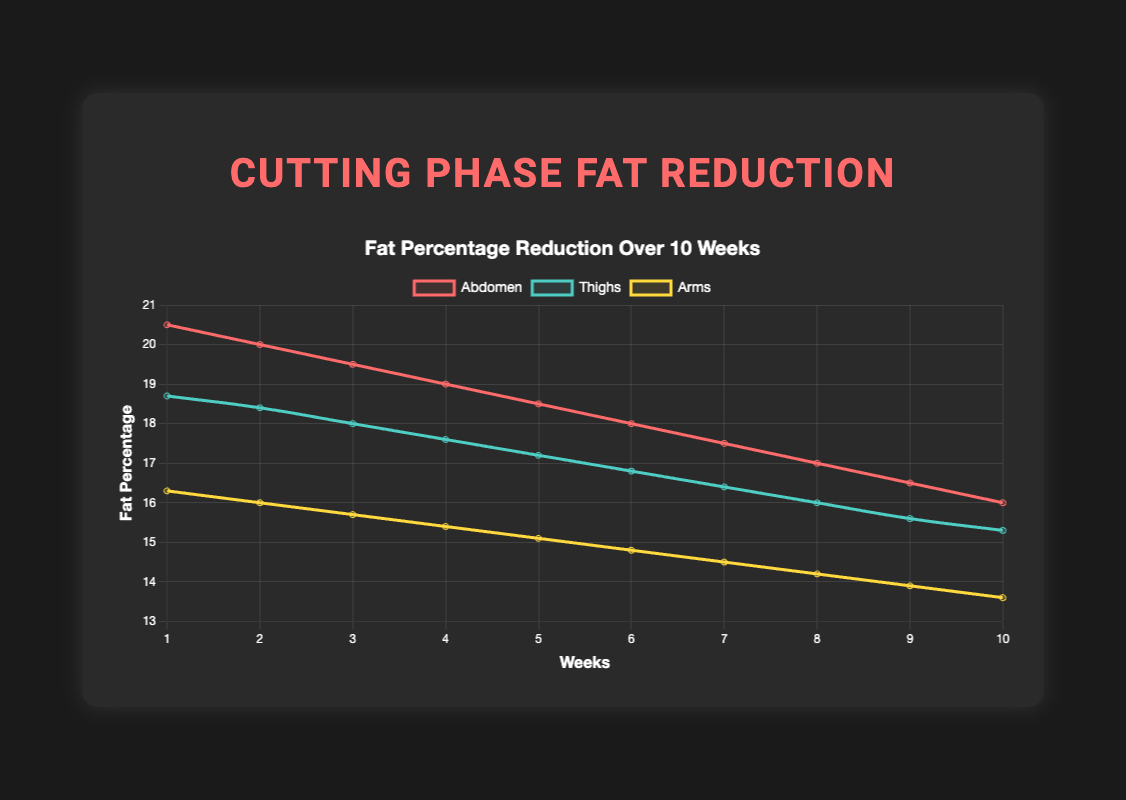What is the initial fat percentage in the abdomen compared to the arms? To determine the initial fat percentages, refer to the y-values at week 1 for the abdomen and arms. The fat percentage for the abdomen is 20.5% and for the arms is 16.3%. Comparing these values, the abdomen fat percentage is higher.
Answer: The abdomen has a higher initial fat percentage than the arms How much total fat percentage reduction is seen in the thighs by week 10? Calculate the difference in fat percentage from week 1 to week 10 for the thighs. The initial fat percentage at week 1 is 18.7% and at week 10 is 15.3%. Subtract the final value from the initial value to get the total reduction: 18.7% - 15.3% = 3.4%.
Answer: 3.4% Which body part has the most significant decrease in fat percentage over 10 weeks? Compare the total reduction in fat percentage from week 1 to week 10 for the abdomen, thighs, and arms. The abdomen reduces from 20.5% to 16.0%, a difference of 4.5%. Thighs reduce from 18.7% to 15.3%, a difference of 3.4%. Arms reduce from 16.3% to 13.6%, a difference of 2.7%. The abdomen shows the most significant decrease of 4.5%.
Answer: Abdomen At week 5, which body part has the lowest fat percentage? Examine the fat percentages at week 5 for the abdomen, thighs, and arms. The values are: Abdomen: 18.5%, Thighs: 17.2%, Arms: 15.1%. The arms have the lowest percentage.
Answer: Arms What is the average fat percentage of the thighs over the 10 weeks? To find the average fat percentage of the thighs, sum the values for all 10 weeks and divide by 10. The sums are 18.7 + 18.4 + 18.0 + 17.6 + 17.2 + 16.8 + 16.4 + 16.0 + 15.6 + 15.3 = 170. The average is 170 / 10 = 17.0%.
Answer: 17.0% How does the fat reduction rate in arms compare to thighs over the entire period? Calculate the rate by comparing the slope of the reductions. For arms, the reduction is 16.3% to 13.6%, a decrease of 2.7% over 10 weeks or 0.27% per week. For thighs, the reduction is 18.7% to 15.3%, a decrease of 3.4% over 10 weeks or 0.34% per week. Thigh reduction rate is higher.
Answer: Thighs have a higher reduction rate By how much does the abdomen fat percentage decrease from week 3 to week 8? Identify values at week 3 and week 8 for the abdomen: 19.5% and 17.0%, respectively. Calculate the difference: 19.5% - 17.0% = 2.5%.
Answer: 2.5% 